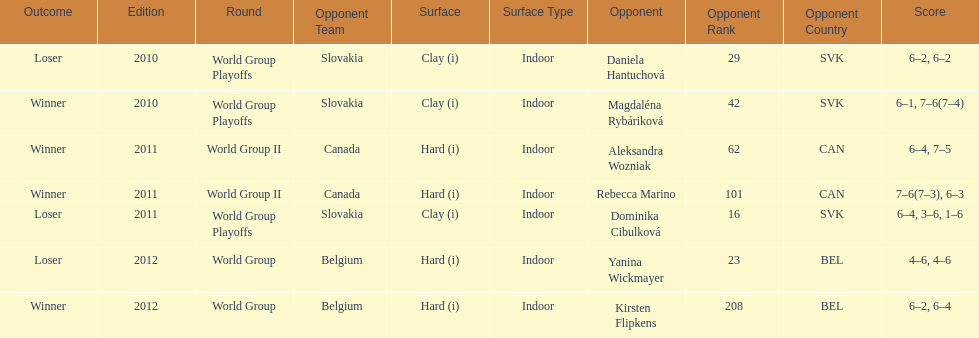What was the next game listed after the world group ii rounds? World Group Playoffs. 